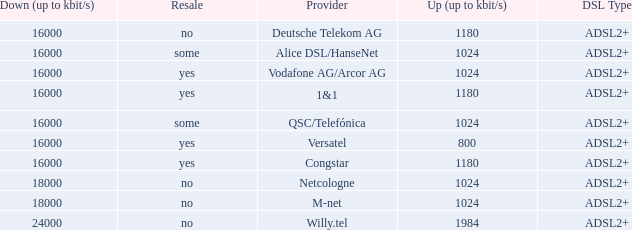Who are all of the telecom providers for which the upload rate is 1024 kbits and the resale category is yes? Vodafone AG/Arcor AG. 